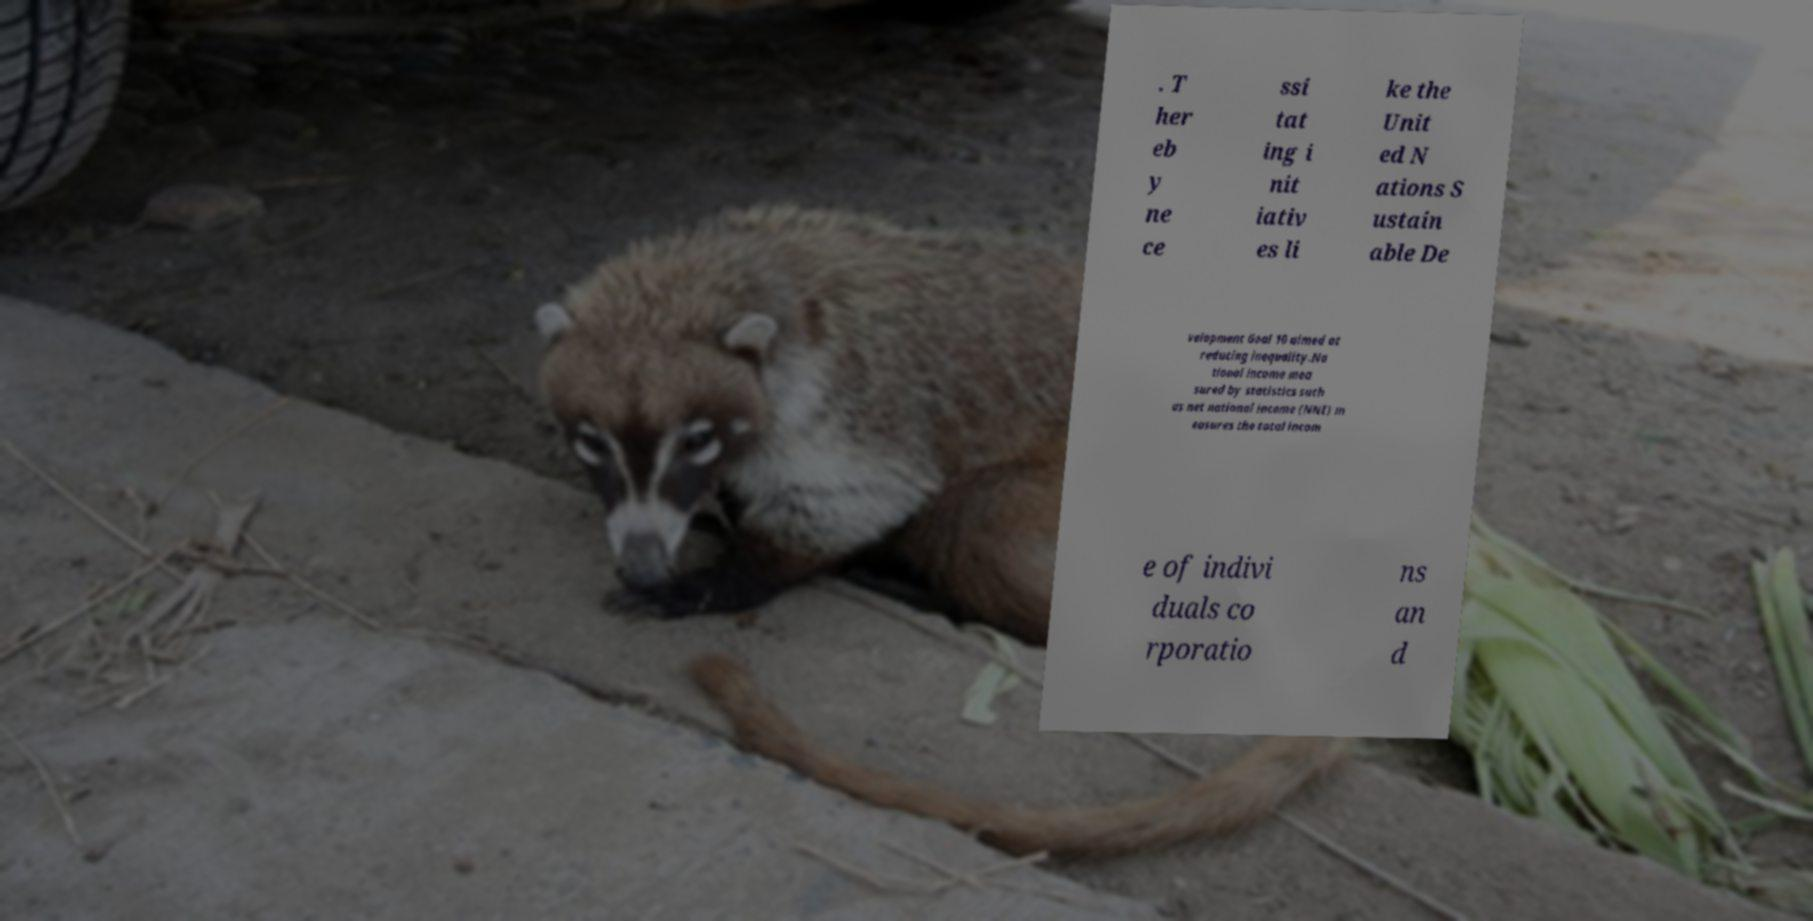Please read and relay the text visible in this image. What does it say? . T her eb y ne ce ssi tat ing i nit iativ es li ke the Unit ed N ations S ustain able De velopment Goal 10 aimed at reducing inequality.Na tional income mea sured by statistics such as net national income (NNI) m easures the total incom e of indivi duals co rporatio ns an d 